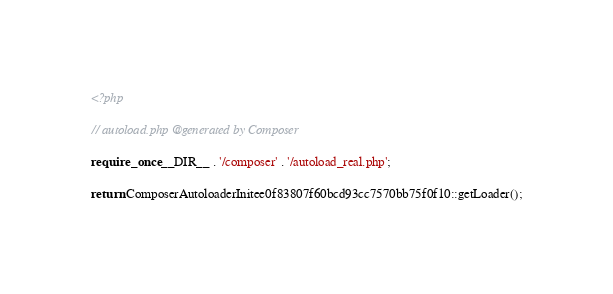Convert code to text. <code><loc_0><loc_0><loc_500><loc_500><_PHP_><?php

// autoload.php @generated by Composer

require_once __DIR__ . '/composer' . '/autoload_real.php';

return ComposerAutoloaderInitee0f83807f60bcd93cc7570bb75f0f10::getLoader();
</code> 